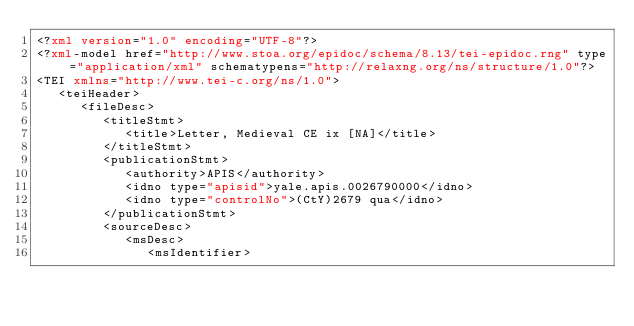<code> <loc_0><loc_0><loc_500><loc_500><_XML_><?xml version="1.0" encoding="UTF-8"?>
<?xml-model href="http://www.stoa.org/epidoc/schema/8.13/tei-epidoc.rng" type="application/xml" schematypens="http://relaxng.org/ns/structure/1.0"?>
<TEI xmlns="http://www.tei-c.org/ns/1.0">
   <teiHeader>
      <fileDesc>
         <titleStmt>
            <title>Letter, Medieval CE ix [NA]</title>
         </titleStmt>
         <publicationStmt>
            <authority>APIS</authority>
            <idno type="apisid">yale.apis.0026790000</idno>
            <idno type="controlNo">(CtY)2679 qua</idno>
         </publicationStmt>
         <sourceDesc>
            <msDesc>
               <msIdentifier></code> 